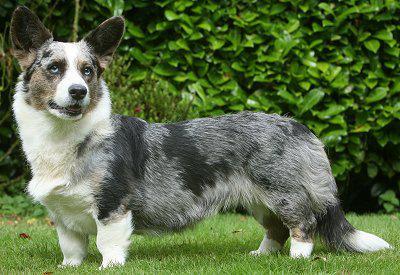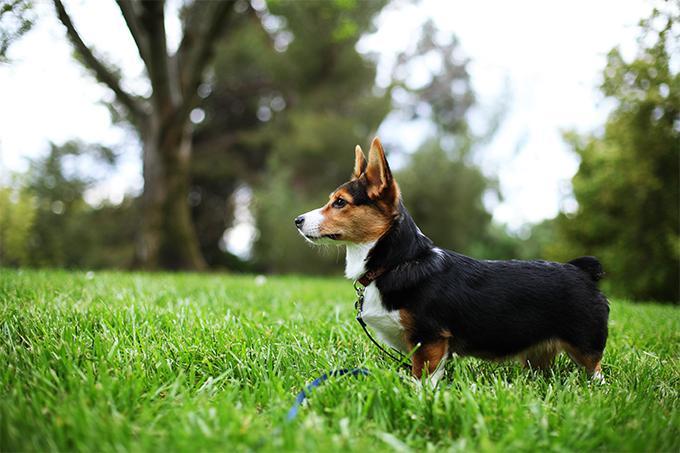The first image is the image on the left, the second image is the image on the right. Evaluate the accuracy of this statement regarding the images: "All dogs shown are on the grass, and at least two dogs in total have their mouths open and tongues showing.". Is it true? Answer yes or no. No. The first image is the image on the left, the second image is the image on the right. Considering the images on both sides, is "At least one dog is sticking the tongue out." valid? Answer yes or no. No. 